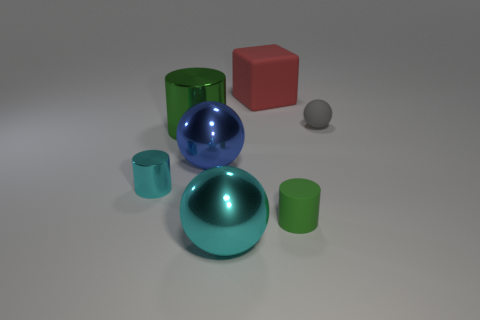The large ball in front of the rubber object in front of the tiny rubber sphere is made of what material?
Your answer should be compact. Metal. What color is the big object that is the same shape as the small green matte object?
Your response must be concise. Green. Are the big cyan sphere and the thing that is behind the tiny gray sphere made of the same material?
Your answer should be very brief. No. What is the color of the small rubber ball?
Give a very brief answer. Gray. The big ball that is in front of the cyan thing on the left side of the big cyan metallic object in front of the rubber block is what color?
Provide a succinct answer. Cyan. There is a large blue object; is it the same shape as the green thing that is on the left side of the large rubber cube?
Provide a succinct answer. No. The large metallic object that is both behind the cyan metallic cylinder and to the right of the large green metal cylinder is what color?
Offer a very short reply. Blue. Are there any big cyan shiny things of the same shape as the tiny gray object?
Your answer should be very brief. Yes. Do the small matte cylinder and the big shiny cylinder have the same color?
Offer a very short reply. Yes. There is a rubber cylinder that is to the left of the tiny sphere; is there a cyan thing that is in front of it?
Your answer should be compact. Yes. 